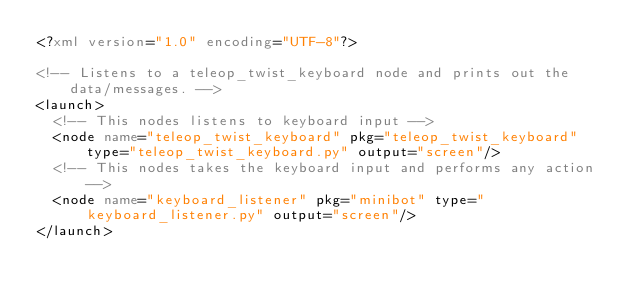<code> <loc_0><loc_0><loc_500><loc_500><_XML_><?xml version="1.0" encoding="UTF-8"?>

<!-- Listens to a teleop_twist_keyboard node and prints out the data/messages. -->
<launch>
  <!-- This nodes listens to keyboard input -->
  <node name="teleop_twist_keyboard" pkg="teleop_twist_keyboard" type="teleop_twist_keyboard.py" output="screen"/>
  <!-- This nodes takes the keyboard input and performs any action -->
  <node name="keyboard_listener" pkg="minibot" type="keyboard_listener.py" output="screen"/>
</launch>
</code> 